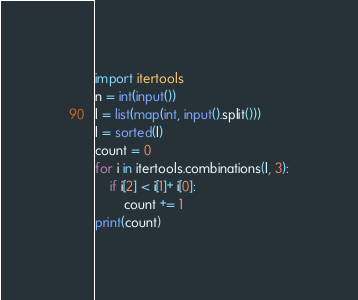Convert code to text. <code><loc_0><loc_0><loc_500><loc_500><_Python_>import itertools
n = int(input())
l = list(map(int, input().split()))
l = sorted(l)
count = 0
for i in itertools.combinations(l, 3):
    if i[2] < i[1]+ i[0]:
        count += 1
print(count)</code> 